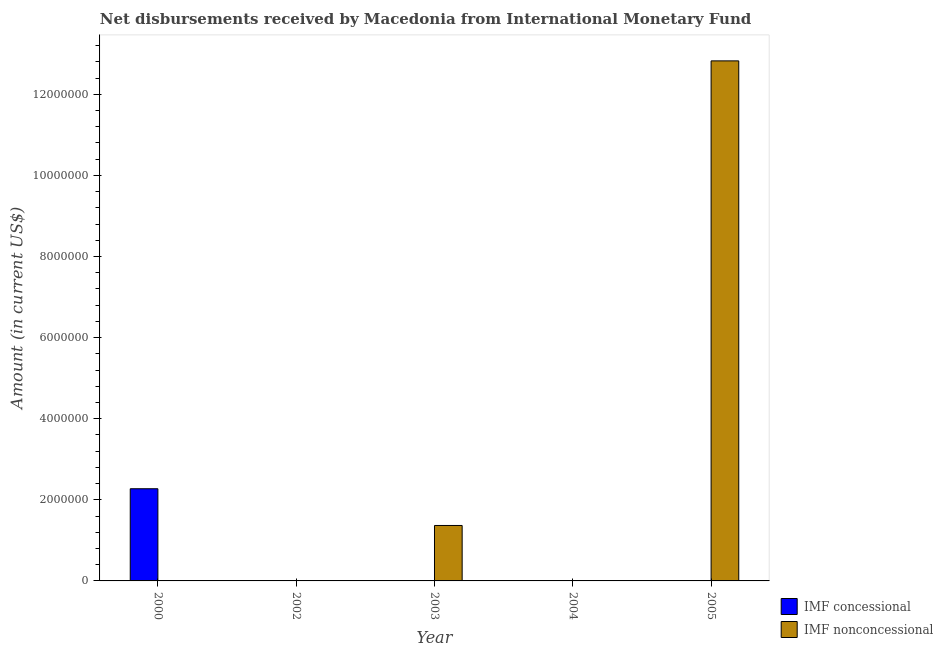Are the number of bars per tick equal to the number of legend labels?
Your answer should be compact. No. Are the number of bars on each tick of the X-axis equal?
Give a very brief answer. No. How many bars are there on the 5th tick from the left?
Provide a succinct answer. 1. Across all years, what is the maximum net non concessional disbursements from imf?
Your answer should be very brief. 1.28e+07. Across all years, what is the minimum net concessional disbursements from imf?
Offer a very short reply. 0. In which year was the net concessional disbursements from imf maximum?
Offer a terse response. 2000. What is the total net concessional disbursements from imf in the graph?
Offer a terse response. 2.27e+06. What is the difference between the net non concessional disbursements from imf in 2003 and that in 2005?
Keep it short and to the point. -1.15e+07. What is the difference between the net concessional disbursements from imf in 2003 and the net non concessional disbursements from imf in 2004?
Make the answer very short. 0. What is the average net non concessional disbursements from imf per year?
Your response must be concise. 2.84e+06. What is the difference between the highest and the lowest net non concessional disbursements from imf?
Provide a succinct answer. 1.28e+07. How many years are there in the graph?
Offer a very short reply. 5. What is the difference between two consecutive major ticks on the Y-axis?
Offer a terse response. 2.00e+06. Does the graph contain any zero values?
Provide a short and direct response. Yes. Does the graph contain grids?
Your response must be concise. No. How many legend labels are there?
Offer a terse response. 2. How are the legend labels stacked?
Keep it short and to the point. Vertical. What is the title of the graph?
Make the answer very short. Net disbursements received by Macedonia from International Monetary Fund. Does "Crop" appear as one of the legend labels in the graph?
Ensure brevity in your answer.  No. What is the label or title of the Y-axis?
Give a very brief answer. Amount (in current US$). What is the Amount (in current US$) of IMF concessional in 2000?
Give a very brief answer. 2.27e+06. What is the Amount (in current US$) of IMF nonconcessional in 2003?
Ensure brevity in your answer.  1.37e+06. What is the Amount (in current US$) of IMF concessional in 2005?
Your answer should be very brief. 0. What is the Amount (in current US$) of IMF nonconcessional in 2005?
Your answer should be compact. 1.28e+07. Across all years, what is the maximum Amount (in current US$) of IMF concessional?
Your answer should be compact. 2.27e+06. Across all years, what is the maximum Amount (in current US$) of IMF nonconcessional?
Make the answer very short. 1.28e+07. What is the total Amount (in current US$) in IMF concessional in the graph?
Provide a succinct answer. 2.27e+06. What is the total Amount (in current US$) in IMF nonconcessional in the graph?
Your answer should be compact. 1.42e+07. What is the difference between the Amount (in current US$) in IMF nonconcessional in 2003 and that in 2005?
Offer a very short reply. -1.15e+07. What is the difference between the Amount (in current US$) in IMF concessional in 2000 and the Amount (in current US$) in IMF nonconcessional in 2003?
Ensure brevity in your answer.  9.06e+05. What is the difference between the Amount (in current US$) of IMF concessional in 2000 and the Amount (in current US$) of IMF nonconcessional in 2005?
Give a very brief answer. -1.06e+07. What is the average Amount (in current US$) in IMF concessional per year?
Give a very brief answer. 4.55e+05. What is the average Amount (in current US$) of IMF nonconcessional per year?
Give a very brief answer. 2.84e+06. What is the ratio of the Amount (in current US$) of IMF nonconcessional in 2003 to that in 2005?
Provide a succinct answer. 0.11. What is the difference between the highest and the lowest Amount (in current US$) of IMF concessional?
Ensure brevity in your answer.  2.27e+06. What is the difference between the highest and the lowest Amount (in current US$) in IMF nonconcessional?
Keep it short and to the point. 1.28e+07. 